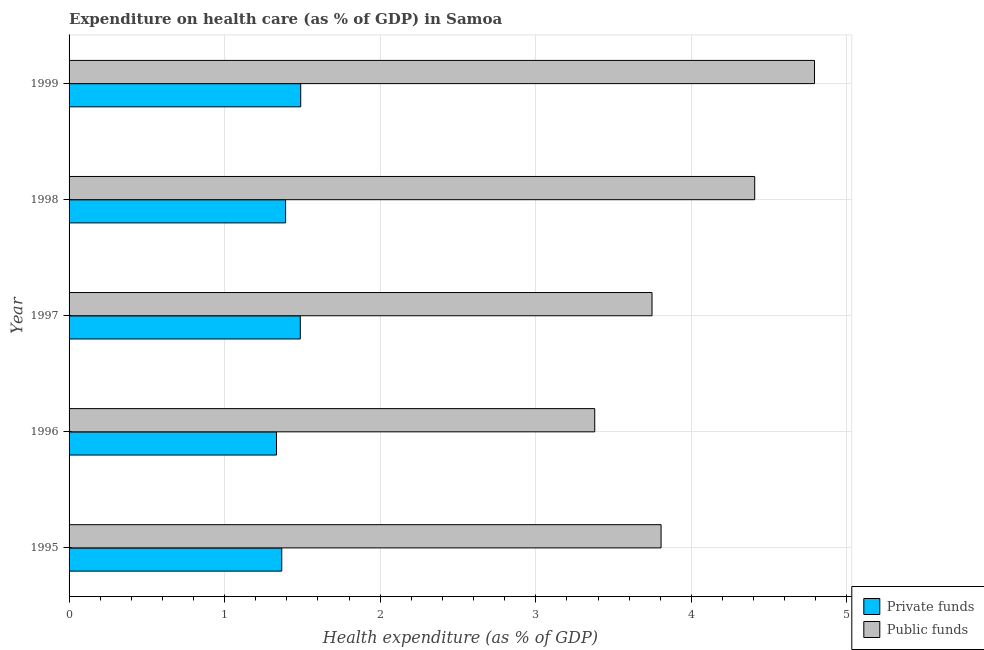Are the number of bars on each tick of the Y-axis equal?
Your answer should be very brief. Yes. How many bars are there on the 3rd tick from the bottom?
Provide a short and direct response. 2. What is the label of the 3rd group of bars from the top?
Offer a very short reply. 1997. In how many cases, is the number of bars for a given year not equal to the number of legend labels?
Make the answer very short. 0. What is the amount of private funds spent in healthcare in 1996?
Give a very brief answer. 1.33. Across all years, what is the maximum amount of public funds spent in healthcare?
Provide a succinct answer. 4.79. Across all years, what is the minimum amount of private funds spent in healthcare?
Offer a very short reply. 1.33. In which year was the amount of private funds spent in healthcare maximum?
Make the answer very short. 1999. What is the total amount of public funds spent in healthcare in the graph?
Provide a short and direct response. 20.13. What is the difference between the amount of private funds spent in healthcare in 1996 and that in 1998?
Your answer should be very brief. -0.06. What is the difference between the amount of private funds spent in healthcare in 1998 and the amount of public funds spent in healthcare in 1997?
Offer a terse response. -2.36. What is the average amount of public funds spent in healthcare per year?
Your answer should be compact. 4.03. In the year 1999, what is the difference between the amount of public funds spent in healthcare and amount of private funds spent in healthcare?
Keep it short and to the point. 3.3. In how many years, is the amount of public funds spent in healthcare greater than 1.4 %?
Provide a succinct answer. 5. What is the ratio of the amount of public funds spent in healthcare in 1995 to that in 1998?
Your answer should be compact. 0.86. Is the difference between the amount of public funds spent in healthcare in 1996 and 1998 greater than the difference between the amount of private funds spent in healthcare in 1996 and 1998?
Provide a short and direct response. No. What is the difference between the highest and the second highest amount of private funds spent in healthcare?
Keep it short and to the point. 0. What is the difference between the highest and the lowest amount of private funds spent in healthcare?
Your answer should be compact. 0.16. In how many years, is the amount of private funds spent in healthcare greater than the average amount of private funds spent in healthcare taken over all years?
Provide a short and direct response. 2. What does the 2nd bar from the top in 1998 represents?
Provide a succinct answer. Private funds. What does the 2nd bar from the bottom in 1997 represents?
Offer a very short reply. Public funds. How many bars are there?
Ensure brevity in your answer.  10. What is the difference between two consecutive major ticks on the X-axis?
Your answer should be compact. 1. Does the graph contain any zero values?
Your answer should be very brief. No. Does the graph contain grids?
Provide a succinct answer. Yes. Where does the legend appear in the graph?
Your answer should be very brief. Bottom right. How many legend labels are there?
Provide a succinct answer. 2. What is the title of the graph?
Offer a very short reply. Expenditure on health care (as % of GDP) in Samoa. What is the label or title of the X-axis?
Your answer should be very brief. Health expenditure (as % of GDP). What is the Health expenditure (as % of GDP) in Private funds in 1995?
Provide a succinct answer. 1.37. What is the Health expenditure (as % of GDP) in Public funds in 1995?
Keep it short and to the point. 3.81. What is the Health expenditure (as % of GDP) of Private funds in 1996?
Your answer should be very brief. 1.33. What is the Health expenditure (as % of GDP) of Public funds in 1996?
Provide a succinct answer. 3.38. What is the Health expenditure (as % of GDP) of Private funds in 1997?
Provide a succinct answer. 1.49. What is the Health expenditure (as % of GDP) of Public funds in 1997?
Your answer should be compact. 3.75. What is the Health expenditure (as % of GDP) of Private funds in 1998?
Offer a very short reply. 1.39. What is the Health expenditure (as % of GDP) of Public funds in 1998?
Offer a terse response. 4.41. What is the Health expenditure (as % of GDP) in Private funds in 1999?
Ensure brevity in your answer.  1.49. What is the Health expenditure (as % of GDP) of Public funds in 1999?
Ensure brevity in your answer.  4.79. Across all years, what is the maximum Health expenditure (as % of GDP) of Private funds?
Offer a terse response. 1.49. Across all years, what is the maximum Health expenditure (as % of GDP) of Public funds?
Make the answer very short. 4.79. Across all years, what is the minimum Health expenditure (as % of GDP) of Private funds?
Offer a very short reply. 1.33. Across all years, what is the minimum Health expenditure (as % of GDP) in Public funds?
Your answer should be very brief. 3.38. What is the total Health expenditure (as % of GDP) of Private funds in the graph?
Your answer should be very brief. 7.07. What is the total Health expenditure (as % of GDP) of Public funds in the graph?
Provide a succinct answer. 20.13. What is the difference between the Health expenditure (as % of GDP) of Private funds in 1995 and that in 1996?
Provide a short and direct response. 0.03. What is the difference between the Health expenditure (as % of GDP) of Public funds in 1995 and that in 1996?
Keep it short and to the point. 0.43. What is the difference between the Health expenditure (as % of GDP) in Private funds in 1995 and that in 1997?
Provide a short and direct response. -0.12. What is the difference between the Health expenditure (as % of GDP) of Public funds in 1995 and that in 1997?
Provide a short and direct response. 0.06. What is the difference between the Health expenditure (as % of GDP) in Private funds in 1995 and that in 1998?
Keep it short and to the point. -0.02. What is the difference between the Health expenditure (as % of GDP) in Public funds in 1995 and that in 1998?
Your answer should be very brief. -0.6. What is the difference between the Health expenditure (as % of GDP) of Private funds in 1995 and that in 1999?
Ensure brevity in your answer.  -0.12. What is the difference between the Health expenditure (as % of GDP) of Public funds in 1995 and that in 1999?
Offer a very short reply. -0.99. What is the difference between the Health expenditure (as % of GDP) of Private funds in 1996 and that in 1997?
Make the answer very short. -0.15. What is the difference between the Health expenditure (as % of GDP) of Public funds in 1996 and that in 1997?
Make the answer very short. -0.37. What is the difference between the Health expenditure (as % of GDP) in Private funds in 1996 and that in 1998?
Give a very brief answer. -0.06. What is the difference between the Health expenditure (as % of GDP) of Public funds in 1996 and that in 1998?
Your answer should be very brief. -1.03. What is the difference between the Health expenditure (as % of GDP) of Private funds in 1996 and that in 1999?
Your response must be concise. -0.16. What is the difference between the Health expenditure (as % of GDP) in Public funds in 1996 and that in 1999?
Ensure brevity in your answer.  -1.41. What is the difference between the Health expenditure (as % of GDP) in Private funds in 1997 and that in 1998?
Give a very brief answer. 0.09. What is the difference between the Health expenditure (as % of GDP) in Public funds in 1997 and that in 1998?
Provide a succinct answer. -0.66. What is the difference between the Health expenditure (as % of GDP) of Private funds in 1997 and that in 1999?
Ensure brevity in your answer.  -0. What is the difference between the Health expenditure (as % of GDP) of Public funds in 1997 and that in 1999?
Your answer should be compact. -1.04. What is the difference between the Health expenditure (as % of GDP) in Private funds in 1998 and that in 1999?
Ensure brevity in your answer.  -0.1. What is the difference between the Health expenditure (as % of GDP) in Public funds in 1998 and that in 1999?
Offer a very short reply. -0.38. What is the difference between the Health expenditure (as % of GDP) of Private funds in 1995 and the Health expenditure (as % of GDP) of Public funds in 1996?
Make the answer very short. -2.01. What is the difference between the Health expenditure (as % of GDP) of Private funds in 1995 and the Health expenditure (as % of GDP) of Public funds in 1997?
Make the answer very short. -2.38. What is the difference between the Health expenditure (as % of GDP) in Private funds in 1995 and the Health expenditure (as % of GDP) in Public funds in 1998?
Your answer should be compact. -3.04. What is the difference between the Health expenditure (as % of GDP) in Private funds in 1995 and the Health expenditure (as % of GDP) in Public funds in 1999?
Your response must be concise. -3.42. What is the difference between the Health expenditure (as % of GDP) of Private funds in 1996 and the Health expenditure (as % of GDP) of Public funds in 1997?
Your answer should be compact. -2.41. What is the difference between the Health expenditure (as % of GDP) in Private funds in 1996 and the Health expenditure (as % of GDP) in Public funds in 1998?
Make the answer very short. -3.07. What is the difference between the Health expenditure (as % of GDP) of Private funds in 1996 and the Health expenditure (as % of GDP) of Public funds in 1999?
Your answer should be compact. -3.46. What is the difference between the Health expenditure (as % of GDP) of Private funds in 1997 and the Health expenditure (as % of GDP) of Public funds in 1998?
Provide a short and direct response. -2.92. What is the difference between the Health expenditure (as % of GDP) of Private funds in 1997 and the Health expenditure (as % of GDP) of Public funds in 1999?
Offer a terse response. -3.31. What is the difference between the Health expenditure (as % of GDP) in Private funds in 1998 and the Health expenditure (as % of GDP) in Public funds in 1999?
Your response must be concise. -3.4. What is the average Health expenditure (as % of GDP) of Private funds per year?
Keep it short and to the point. 1.41. What is the average Health expenditure (as % of GDP) of Public funds per year?
Your answer should be very brief. 4.03. In the year 1995, what is the difference between the Health expenditure (as % of GDP) in Private funds and Health expenditure (as % of GDP) in Public funds?
Give a very brief answer. -2.44. In the year 1996, what is the difference between the Health expenditure (as % of GDP) in Private funds and Health expenditure (as % of GDP) in Public funds?
Provide a short and direct response. -2.05. In the year 1997, what is the difference between the Health expenditure (as % of GDP) of Private funds and Health expenditure (as % of GDP) of Public funds?
Your answer should be very brief. -2.26. In the year 1998, what is the difference between the Health expenditure (as % of GDP) of Private funds and Health expenditure (as % of GDP) of Public funds?
Your answer should be compact. -3.02. In the year 1999, what is the difference between the Health expenditure (as % of GDP) of Private funds and Health expenditure (as % of GDP) of Public funds?
Your answer should be very brief. -3.3. What is the ratio of the Health expenditure (as % of GDP) in Private funds in 1995 to that in 1996?
Your answer should be compact. 1.03. What is the ratio of the Health expenditure (as % of GDP) in Public funds in 1995 to that in 1996?
Keep it short and to the point. 1.13. What is the ratio of the Health expenditure (as % of GDP) of Private funds in 1995 to that in 1997?
Give a very brief answer. 0.92. What is the ratio of the Health expenditure (as % of GDP) in Public funds in 1995 to that in 1997?
Keep it short and to the point. 1.02. What is the ratio of the Health expenditure (as % of GDP) of Private funds in 1995 to that in 1998?
Provide a short and direct response. 0.98. What is the ratio of the Health expenditure (as % of GDP) in Public funds in 1995 to that in 1998?
Make the answer very short. 0.86. What is the ratio of the Health expenditure (as % of GDP) in Private funds in 1995 to that in 1999?
Provide a succinct answer. 0.92. What is the ratio of the Health expenditure (as % of GDP) of Public funds in 1995 to that in 1999?
Provide a short and direct response. 0.79. What is the ratio of the Health expenditure (as % of GDP) of Private funds in 1996 to that in 1997?
Give a very brief answer. 0.9. What is the ratio of the Health expenditure (as % of GDP) of Public funds in 1996 to that in 1997?
Your response must be concise. 0.9. What is the ratio of the Health expenditure (as % of GDP) in Private funds in 1996 to that in 1998?
Offer a very short reply. 0.96. What is the ratio of the Health expenditure (as % of GDP) in Public funds in 1996 to that in 1998?
Provide a succinct answer. 0.77. What is the ratio of the Health expenditure (as % of GDP) in Private funds in 1996 to that in 1999?
Give a very brief answer. 0.9. What is the ratio of the Health expenditure (as % of GDP) of Public funds in 1996 to that in 1999?
Provide a short and direct response. 0.71. What is the ratio of the Health expenditure (as % of GDP) of Private funds in 1997 to that in 1998?
Your answer should be very brief. 1.07. What is the ratio of the Health expenditure (as % of GDP) of Public funds in 1997 to that in 1998?
Provide a short and direct response. 0.85. What is the ratio of the Health expenditure (as % of GDP) in Public funds in 1997 to that in 1999?
Your response must be concise. 0.78. What is the ratio of the Health expenditure (as % of GDP) of Private funds in 1998 to that in 1999?
Make the answer very short. 0.93. What is the ratio of the Health expenditure (as % of GDP) in Public funds in 1998 to that in 1999?
Provide a short and direct response. 0.92. What is the difference between the highest and the second highest Health expenditure (as % of GDP) in Private funds?
Ensure brevity in your answer.  0. What is the difference between the highest and the second highest Health expenditure (as % of GDP) of Public funds?
Make the answer very short. 0.38. What is the difference between the highest and the lowest Health expenditure (as % of GDP) in Private funds?
Keep it short and to the point. 0.16. What is the difference between the highest and the lowest Health expenditure (as % of GDP) in Public funds?
Your response must be concise. 1.41. 